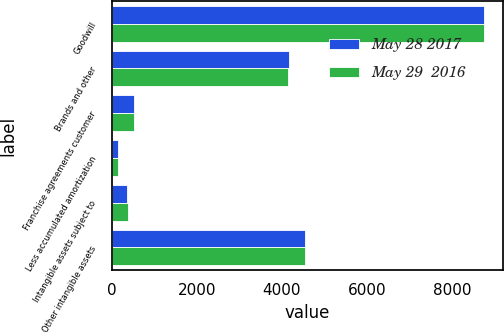<chart> <loc_0><loc_0><loc_500><loc_500><stacked_bar_chart><ecel><fcel>Goodwill<fcel>Brands and other<fcel>Franchise agreements customer<fcel>Less accumulated amortization<fcel>Intangible assets subject to<fcel>Other intangible assets<nl><fcel>May 28 2017<fcel>8747.2<fcel>4161.1<fcel>524.8<fcel>155.5<fcel>369.3<fcel>4530.4<nl><fcel>May 29  2016<fcel>8741.2<fcel>4147.5<fcel>536.9<fcel>145.8<fcel>391.1<fcel>4538.6<nl></chart> 